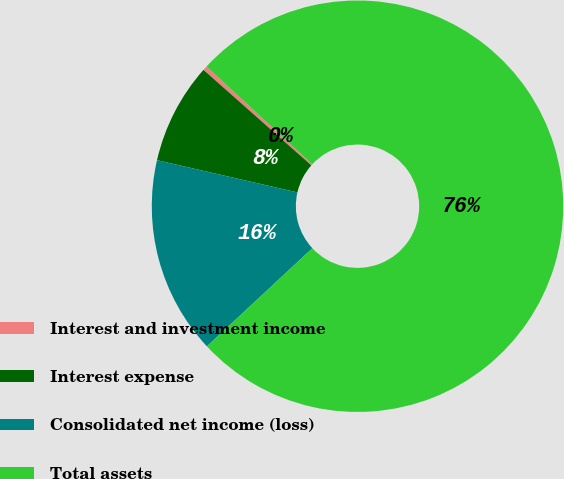Convert chart. <chart><loc_0><loc_0><loc_500><loc_500><pie_chart><fcel>Interest and investment income<fcel>Interest expense<fcel>Consolidated net income (loss)<fcel>Total assets<nl><fcel>0.35%<fcel>7.94%<fcel>15.52%<fcel>76.19%<nl></chart> 